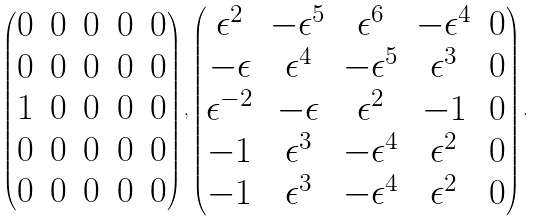<formula> <loc_0><loc_0><loc_500><loc_500>\begin{pmatrix} 0 & 0 & 0 & 0 & 0 \\ 0 & 0 & 0 & 0 & 0 \\ 1 & 0 & 0 & 0 & 0 \\ 0 & 0 & 0 & 0 & 0 \\ 0 & 0 & 0 & 0 & 0 \\ \end{pmatrix} , \begin{pmatrix} \epsilon ^ { 2 } & - \epsilon ^ { 5 } & \epsilon ^ { 6 } & - \epsilon ^ { 4 } & 0 \\ - \epsilon & \epsilon ^ { 4 } & - \epsilon ^ { 5 } & \epsilon ^ { 3 } & 0 \\ \epsilon ^ { - 2 } & - \epsilon & \epsilon ^ { 2 } & - 1 & 0 \\ - 1 & \epsilon ^ { 3 } & - \epsilon ^ { 4 } & \epsilon ^ { 2 } & 0 \\ - 1 & \epsilon ^ { 3 } & - \epsilon ^ { 4 } & \epsilon ^ { 2 } & 0 \\ \end{pmatrix} .</formula> 